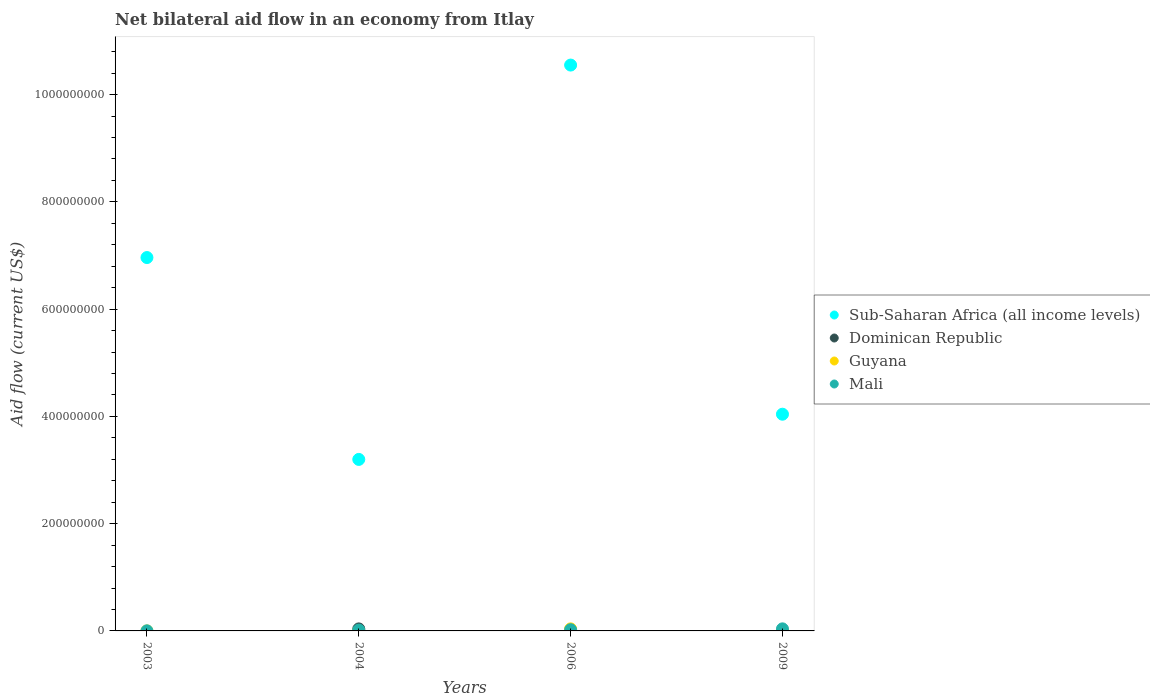What is the net bilateral aid flow in Mali in 2006?
Your answer should be very brief. 2.22e+06. Across all years, what is the maximum net bilateral aid flow in Guyana?
Ensure brevity in your answer.  3.82e+06. Across all years, what is the minimum net bilateral aid flow in Sub-Saharan Africa (all income levels)?
Ensure brevity in your answer.  3.20e+08. What is the total net bilateral aid flow in Guyana in the graph?
Offer a very short reply. 3.87e+06. What is the difference between the net bilateral aid flow in Mali in 2006 and the net bilateral aid flow in Guyana in 2003?
Offer a terse response. 2.21e+06. What is the average net bilateral aid flow in Dominican Republic per year?
Offer a terse response. 9.45e+05. In the year 2004, what is the difference between the net bilateral aid flow in Mali and net bilateral aid flow in Guyana?
Keep it short and to the point. 1.53e+06. What is the ratio of the net bilateral aid flow in Mali in 2004 to that in 2006?
Offer a very short reply. 0.7. Is the difference between the net bilateral aid flow in Mali in 2003 and 2006 greater than the difference between the net bilateral aid flow in Guyana in 2003 and 2006?
Your answer should be very brief. Yes. What is the difference between the highest and the second highest net bilateral aid flow in Mali?
Keep it short and to the point. 1.63e+06. What is the difference between the highest and the lowest net bilateral aid flow in Dominican Republic?
Offer a terse response. 3.78e+06. In how many years, is the net bilateral aid flow in Guyana greater than the average net bilateral aid flow in Guyana taken over all years?
Your answer should be compact. 1. Is the sum of the net bilateral aid flow in Guyana in 2006 and 2009 greater than the maximum net bilateral aid flow in Mali across all years?
Ensure brevity in your answer.  No. Is the net bilateral aid flow in Mali strictly greater than the net bilateral aid flow in Guyana over the years?
Keep it short and to the point. No. Is the net bilateral aid flow in Sub-Saharan Africa (all income levels) strictly less than the net bilateral aid flow in Guyana over the years?
Your answer should be very brief. No. How many dotlines are there?
Ensure brevity in your answer.  4. How many years are there in the graph?
Provide a succinct answer. 4. Are the values on the major ticks of Y-axis written in scientific E-notation?
Ensure brevity in your answer.  No. Where does the legend appear in the graph?
Your answer should be very brief. Center right. What is the title of the graph?
Offer a terse response. Net bilateral aid flow in an economy from Itlay. Does "Czech Republic" appear as one of the legend labels in the graph?
Keep it short and to the point. No. What is the label or title of the X-axis?
Ensure brevity in your answer.  Years. What is the Aid flow (current US$) of Sub-Saharan Africa (all income levels) in 2003?
Provide a succinct answer. 6.96e+08. What is the Aid flow (current US$) of Dominican Republic in 2003?
Keep it short and to the point. 0. What is the Aid flow (current US$) in Mali in 2003?
Provide a short and direct response. 1.30e+05. What is the Aid flow (current US$) of Sub-Saharan Africa (all income levels) in 2004?
Your answer should be compact. 3.20e+08. What is the Aid flow (current US$) of Dominican Republic in 2004?
Provide a short and direct response. 3.78e+06. What is the Aid flow (current US$) of Guyana in 2004?
Keep it short and to the point. 2.00e+04. What is the Aid flow (current US$) in Mali in 2004?
Ensure brevity in your answer.  1.55e+06. What is the Aid flow (current US$) in Sub-Saharan Africa (all income levels) in 2006?
Provide a short and direct response. 1.06e+09. What is the Aid flow (current US$) in Guyana in 2006?
Ensure brevity in your answer.  3.82e+06. What is the Aid flow (current US$) in Mali in 2006?
Keep it short and to the point. 2.22e+06. What is the Aid flow (current US$) of Sub-Saharan Africa (all income levels) in 2009?
Give a very brief answer. 4.04e+08. What is the Aid flow (current US$) of Guyana in 2009?
Offer a very short reply. 2.00e+04. What is the Aid flow (current US$) in Mali in 2009?
Ensure brevity in your answer.  3.85e+06. Across all years, what is the maximum Aid flow (current US$) of Sub-Saharan Africa (all income levels)?
Provide a succinct answer. 1.06e+09. Across all years, what is the maximum Aid flow (current US$) in Dominican Republic?
Your answer should be compact. 3.78e+06. Across all years, what is the maximum Aid flow (current US$) of Guyana?
Provide a succinct answer. 3.82e+06. Across all years, what is the maximum Aid flow (current US$) of Mali?
Your answer should be very brief. 3.85e+06. Across all years, what is the minimum Aid flow (current US$) of Sub-Saharan Africa (all income levels)?
Your response must be concise. 3.20e+08. Across all years, what is the minimum Aid flow (current US$) of Dominican Republic?
Keep it short and to the point. 0. Across all years, what is the minimum Aid flow (current US$) of Mali?
Your answer should be compact. 1.30e+05. What is the total Aid flow (current US$) in Sub-Saharan Africa (all income levels) in the graph?
Your answer should be very brief. 2.48e+09. What is the total Aid flow (current US$) in Dominican Republic in the graph?
Provide a short and direct response. 3.78e+06. What is the total Aid flow (current US$) in Guyana in the graph?
Your answer should be very brief. 3.87e+06. What is the total Aid flow (current US$) of Mali in the graph?
Your answer should be very brief. 7.75e+06. What is the difference between the Aid flow (current US$) in Sub-Saharan Africa (all income levels) in 2003 and that in 2004?
Your answer should be very brief. 3.76e+08. What is the difference between the Aid flow (current US$) in Guyana in 2003 and that in 2004?
Make the answer very short. -10000. What is the difference between the Aid flow (current US$) of Mali in 2003 and that in 2004?
Give a very brief answer. -1.42e+06. What is the difference between the Aid flow (current US$) in Sub-Saharan Africa (all income levels) in 2003 and that in 2006?
Your answer should be very brief. -3.59e+08. What is the difference between the Aid flow (current US$) in Guyana in 2003 and that in 2006?
Give a very brief answer. -3.81e+06. What is the difference between the Aid flow (current US$) in Mali in 2003 and that in 2006?
Your answer should be compact. -2.09e+06. What is the difference between the Aid flow (current US$) in Sub-Saharan Africa (all income levels) in 2003 and that in 2009?
Give a very brief answer. 2.92e+08. What is the difference between the Aid flow (current US$) in Guyana in 2003 and that in 2009?
Your answer should be compact. -10000. What is the difference between the Aid flow (current US$) in Mali in 2003 and that in 2009?
Offer a terse response. -3.72e+06. What is the difference between the Aid flow (current US$) in Sub-Saharan Africa (all income levels) in 2004 and that in 2006?
Make the answer very short. -7.35e+08. What is the difference between the Aid flow (current US$) in Guyana in 2004 and that in 2006?
Give a very brief answer. -3.80e+06. What is the difference between the Aid flow (current US$) in Mali in 2004 and that in 2006?
Provide a short and direct response. -6.70e+05. What is the difference between the Aid flow (current US$) of Sub-Saharan Africa (all income levels) in 2004 and that in 2009?
Provide a short and direct response. -8.43e+07. What is the difference between the Aid flow (current US$) in Guyana in 2004 and that in 2009?
Give a very brief answer. 0. What is the difference between the Aid flow (current US$) of Mali in 2004 and that in 2009?
Ensure brevity in your answer.  -2.30e+06. What is the difference between the Aid flow (current US$) in Sub-Saharan Africa (all income levels) in 2006 and that in 2009?
Give a very brief answer. 6.51e+08. What is the difference between the Aid flow (current US$) of Guyana in 2006 and that in 2009?
Give a very brief answer. 3.80e+06. What is the difference between the Aid flow (current US$) of Mali in 2006 and that in 2009?
Make the answer very short. -1.63e+06. What is the difference between the Aid flow (current US$) of Sub-Saharan Africa (all income levels) in 2003 and the Aid flow (current US$) of Dominican Republic in 2004?
Ensure brevity in your answer.  6.92e+08. What is the difference between the Aid flow (current US$) in Sub-Saharan Africa (all income levels) in 2003 and the Aid flow (current US$) in Guyana in 2004?
Give a very brief answer. 6.96e+08. What is the difference between the Aid flow (current US$) of Sub-Saharan Africa (all income levels) in 2003 and the Aid flow (current US$) of Mali in 2004?
Give a very brief answer. 6.95e+08. What is the difference between the Aid flow (current US$) in Guyana in 2003 and the Aid flow (current US$) in Mali in 2004?
Provide a short and direct response. -1.54e+06. What is the difference between the Aid flow (current US$) of Sub-Saharan Africa (all income levels) in 2003 and the Aid flow (current US$) of Guyana in 2006?
Your response must be concise. 6.92e+08. What is the difference between the Aid flow (current US$) in Sub-Saharan Africa (all income levels) in 2003 and the Aid flow (current US$) in Mali in 2006?
Offer a very short reply. 6.94e+08. What is the difference between the Aid flow (current US$) of Guyana in 2003 and the Aid flow (current US$) of Mali in 2006?
Provide a succinct answer. -2.21e+06. What is the difference between the Aid flow (current US$) in Sub-Saharan Africa (all income levels) in 2003 and the Aid flow (current US$) in Guyana in 2009?
Your answer should be compact. 6.96e+08. What is the difference between the Aid flow (current US$) of Sub-Saharan Africa (all income levels) in 2003 and the Aid flow (current US$) of Mali in 2009?
Provide a short and direct response. 6.92e+08. What is the difference between the Aid flow (current US$) of Guyana in 2003 and the Aid flow (current US$) of Mali in 2009?
Provide a succinct answer. -3.84e+06. What is the difference between the Aid flow (current US$) in Sub-Saharan Africa (all income levels) in 2004 and the Aid flow (current US$) in Guyana in 2006?
Provide a succinct answer. 3.16e+08. What is the difference between the Aid flow (current US$) of Sub-Saharan Africa (all income levels) in 2004 and the Aid flow (current US$) of Mali in 2006?
Keep it short and to the point. 3.18e+08. What is the difference between the Aid flow (current US$) of Dominican Republic in 2004 and the Aid flow (current US$) of Mali in 2006?
Offer a terse response. 1.56e+06. What is the difference between the Aid flow (current US$) in Guyana in 2004 and the Aid flow (current US$) in Mali in 2006?
Your answer should be very brief. -2.20e+06. What is the difference between the Aid flow (current US$) in Sub-Saharan Africa (all income levels) in 2004 and the Aid flow (current US$) in Guyana in 2009?
Your response must be concise. 3.20e+08. What is the difference between the Aid flow (current US$) in Sub-Saharan Africa (all income levels) in 2004 and the Aid flow (current US$) in Mali in 2009?
Your response must be concise. 3.16e+08. What is the difference between the Aid flow (current US$) in Dominican Republic in 2004 and the Aid flow (current US$) in Guyana in 2009?
Keep it short and to the point. 3.76e+06. What is the difference between the Aid flow (current US$) of Guyana in 2004 and the Aid flow (current US$) of Mali in 2009?
Give a very brief answer. -3.83e+06. What is the difference between the Aid flow (current US$) of Sub-Saharan Africa (all income levels) in 2006 and the Aid flow (current US$) of Guyana in 2009?
Your answer should be compact. 1.06e+09. What is the difference between the Aid flow (current US$) in Sub-Saharan Africa (all income levels) in 2006 and the Aid flow (current US$) in Mali in 2009?
Provide a succinct answer. 1.05e+09. What is the average Aid flow (current US$) in Sub-Saharan Africa (all income levels) per year?
Keep it short and to the point. 6.19e+08. What is the average Aid flow (current US$) in Dominican Republic per year?
Your response must be concise. 9.45e+05. What is the average Aid flow (current US$) of Guyana per year?
Your response must be concise. 9.68e+05. What is the average Aid flow (current US$) in Mali per year?
Offer a terse response. 1.94e+06. In the year 2003, what is the difference between the Aid flow (current US$) in Sub-Saharan Africa (all income levels) and Aid flow (current US$) in Guyana?
Offer a terse response. 6.96e+08. In the year 2003, what is the difference between the Aid flow (current US$) of Sub-Saharan Africa (all income levels) and Aid flow (current US$) of Mali?
Provide a short and direct response. 6.96e+08. In the year 2004, what is the difference between the Aid flow (current US$) of Sub-Saharan Africa (all income levels) and Aid flow (current US$) of Dominican Republic?
Provide a succinct answer. 3.16e+08. In the year 2004, what is the difference between the Aid flow (current US$) of Sub-Saharan Africa (all income levels) and Aid flow (current US$) of Guyana?
Keep it short and to the point. 3.20e+08. In the year 2004, what is the difference between the Aid flow (current US$) of Sub-Saharan Africa (all income levels) and Aid flow (current US$) of Mali?
Provide a short and direct response. 3.18e+08. In the year 2004, what is the difference between the Aid flow (current US$) in Dominican Republic and Aid flow (current US$) in Guyana?
Offer a terse response. 3.76e+06. In the year 2004, what is the difference between the Aid flow (current US$) in Dominican Republic and Aid flow (current US$) in Mali?
Make the answer very short. 2.23e+06. In the year 2004, what is the difference between the Aid flow (current US$) of Guyana and Aid flow (current US$) of Mali?
Your response must be concise. -1.53e+06. In the year 2006, what is the difference between the Aid flow (current US$) of Sub-Saharan Africa (all income levels) and Aid flow (current US$) of Guyana?
Offer a terse response. 1.05e+09. In the year 2006, what is the difference between the Aid flow (current US$) of Sub-Saharan Africa (all income levels) and Aid flow (current US$) of Mali?
Offer a terse response. 1.05e+09. In the year 2006, what is the difference between the Aid flow (current US$) of Guyana and Aid flow (current US$) of Mali?
Your response must be concise. 1.60e+06. In the year 2009, what is the difference between the Aid flow (current US$) in Sub-Saharan Africa (all income levels) and Aid flow (current US$) in Guyana?
Give a very brief answer. 4.04e+08. In the year 2009, what is the difference between the Aid flow (current US$) in Sub-Saharan Africa (all income levels) and Aid flow (current US$) in Mali?
Provide a succinct answer. 4.00e+08. In the year 2009, what is the difference between the Aid flow (current US$) in Guyana and Aid flow (current US$) in Mali?
Offer a very short reply. -3.83e+06. What is the ratio of the Aid flow (current US$) in Sub-Saharan Africa (all income levels) in 2003 to that in 2004?
Offer a terse response. 2.18. What is the ratio of the Aid flow (current US$) of Mali in 2003 to that in 2004?
Keep it short and to the point. 0.08. What is the ratio of the Aid flow (current US$) of Sub-Saharan Africa (all income levels) in 2003 to that in 2006?
Provide a short and direct response. 0.66. What is the ratio of the Aid flow (current US$) in Guyana in 2003 to that in 2006?
Provide a short and direct response. 0. What is the ratio of the Aid flow (current US$) in Mali in 2003 to that in 2006?
Keep it short and to the point. 0.06. What is the ratio of the Aid flow (current US$) of Sub-Saharan Africa (all income levels) in 2003 to that in 2009?
Give a very brief answer. 1.72. What is the ratio of the Aid flow (current US$) of Mali in 2003 to that in 2009?
Keep it short and to the point. 0.03. What is the ratio of the Aid flow (current US$) in Sub-Saharan Africa (all income levels) in 2004 to that in 2006?
Offer a very short reply. 0.3. What is the ratio of the Aid flow (current US$) in Guyana in 2004 to that in 2006?
Your response must be concise. 0.01. What is the ratio of the Aid flow (current US$) in Mali in 2004 to that in 2006?
Your answer should be very brief. 0.7. What is the ratio of the Aid flow (current US$) of Sub-Saharan Africa (all income levels) in 2004 to that in 2009?
Give a very brief answer. 0.79. What is the ratio of the Aid flow (current US$) in Mali in 2004 to that in 2009?
Provide a short and direct response. 0.4. What is the ratio of the Aid flow (current US$) in Sub-Saharan Africa (all income levels) in 2006 to that in 2009?
Keep it short and to the point. 2.61. What is the ratio of the Aid flow (current US$) of Guyana in 2006 to that in 2009?
Provide a short and direct response. 191. What is the ratio of the Aid flow (current US$) of Mali in 2006 to that in 2009?
Offer a terse response. 0.58. What is the difference between the highest and the second highest Aid flow (current US$) in Sub-Saharan Africa (all income levels)?
Offer a very short reply. 3.59e+08. What is the difference between the highest and the second highest Aid flow (current US$) of Guyana?
Your answer should be compact. 3.80e+06. What is the difference between the highest and the second highest Aid flow (current US$) of Mali?
Your answer should be compact. 1.63e+06. What is the difference between the highest and the lowest Aid flow (current US$) of Sub-Saharan Africa (all income levels)?
Your response must be concise. 7.35e+08. What is the difference between the highest and the lowest Aid flow (current US$) in Dominican Republic?
Give a very brief answer. 3.78e+06. What is the difference between the highest and the lowest Aid flow (current US$) in Guyana?
Your answer should be compact. 3.81e+06. What is the difference between the highest and the lowest Aid flow (current US$) of Mali?
Provide a short and direct response. 3.72e+06. 